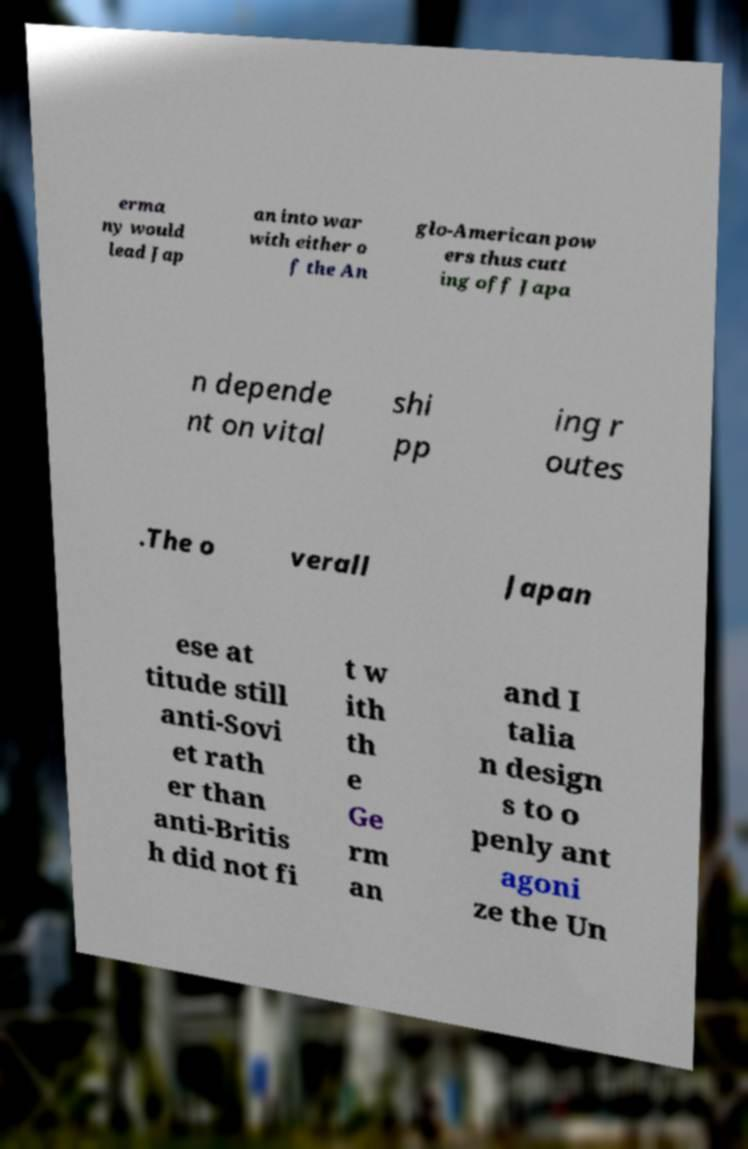Please identify and transcribe the text found in this image. erma ny would lead Jap an into war with either o f the An glo-American pow ers thus cutt ing off Japa n depende nt on vital shi pp ing r outes .The o verall Japan ese at titude still anti-Sovi et rath er than anti-Britis h did not fi t w ith th e Ge rm an and I talia n design s to o penly ant agoni ze the Un 